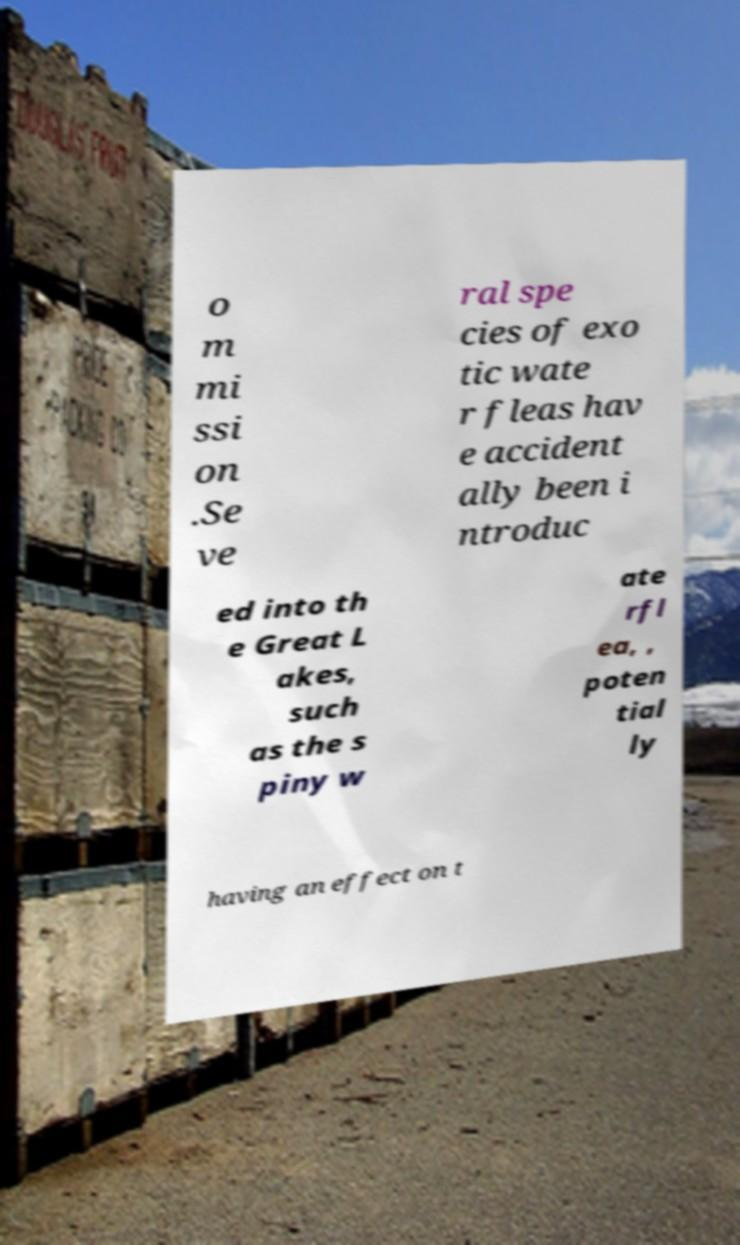Please identify and transcribe the text found in this image. o m mi ssi on .Se ve ral spe cies of exo tic wate r fleas hav e accident ally been i ntroduc ed into th e Great L akes, such as the s piny w ate rfl ea, , poten tial ly having an effect on t 